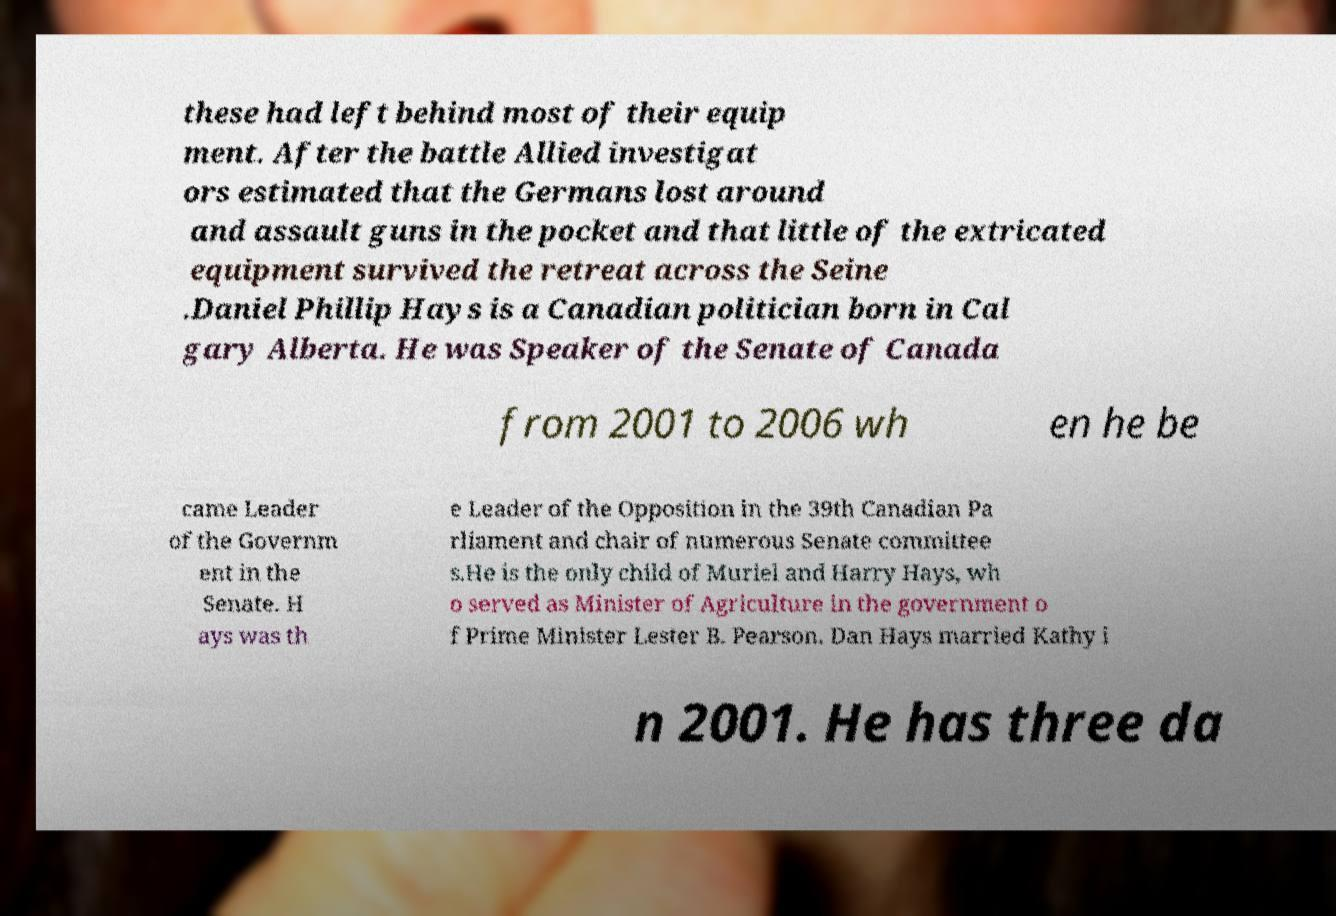Can you read and provide the text displayed in the image?This photo seems to have some interesting text. Can you extract and type it out for me? these had left behind most of their equip ment. After the battle Allied investigat ors estimated that the Germans lost around and assault guns in the pocket and that little of the extricated equipment survived the retreat across the Seine .Daniel Phillip Hays is a Canadian politician born in Cal gary Alberta. He was Speaker of the Senate of Canada from 2001 to 2006 wh en he be came Leader of the Governm ent in the Senate. H ays was th e Leader of the Opposition in the 39th Canadian Pa rliament and chair of numerous Senate committee s.He is the only child of Muriel and Harry Hays, wh o served as Minister of Agriculture in the government o f Prime Minister Lester B. Pearson. Dan Hays married Kathy i n 2001. He has three da 